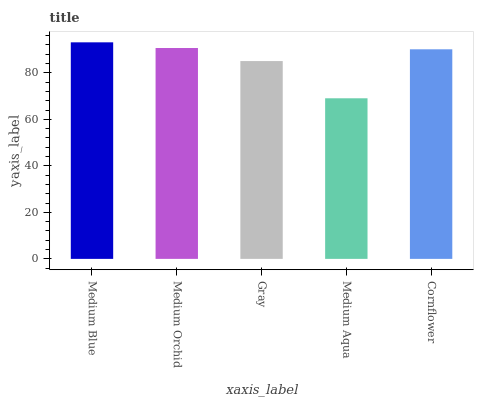Is Medium Aqua the minimum?
Answer yes or no. Yes. Is Medium Blue the maximum?
Answer yes or no. Yes. Is Medium Orchid the minimum?
Answer yes or no. No. Is Medium Orchid the maximum?
Answer yes or no. No. Is Medium Blue greater than Medium Orchid?
Answer yes or no. Yes. Is Medium Orchid less than Medium Blue?
Answer yes or no. Yes. Is Medium Orchid greater than Medium Blue?
Answer yes or no. No. Is Medium Blue less than Medium Orchid?
Answer yes or no. No. Is Cornflower the high median?
Answer yes or no. Yes. Is Cornflower the low median?
Answer yes or no. Yes. Is Medium Blue the high median?
Answer yes or no. No. Is Medium Blue the low median?
Answer yes or no. No. 